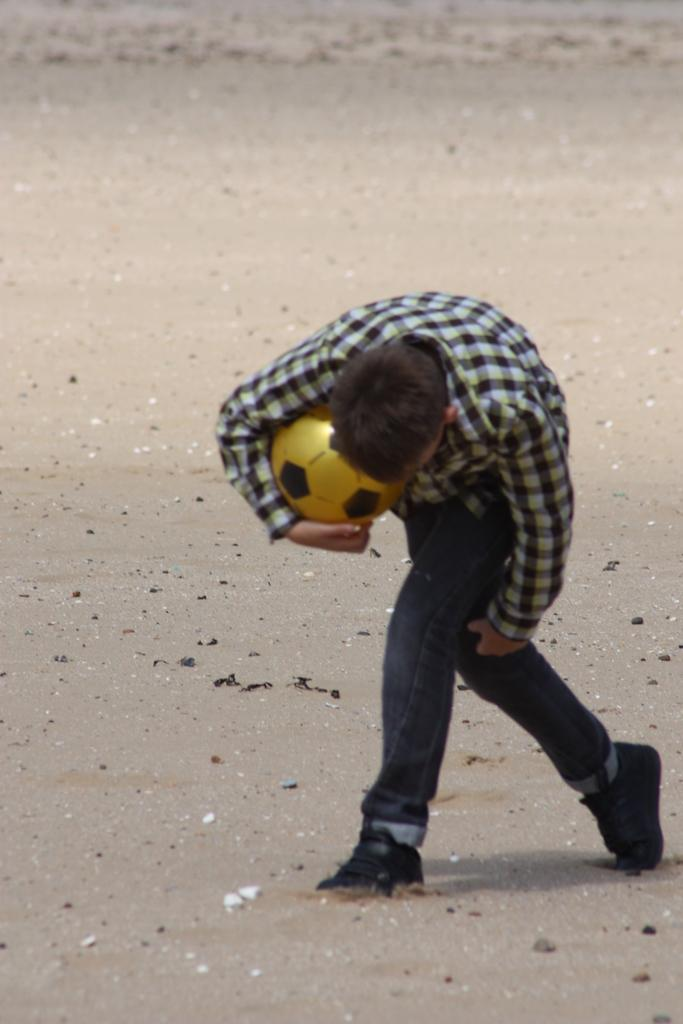What is the primary setting of the image? There is a ground in the image. Who or what can be seen in the image? There is a man in the image. What is the man holding in the image? The man is holding a yellow color ball. What type of poison is the man using to control the crow in the image? There is no crow or poison present in the image; it only features a man holding a yellow color ball. 